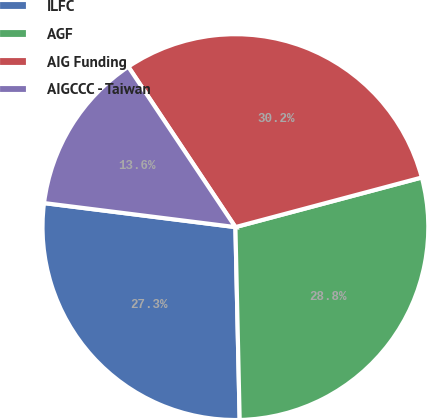Convert chart. <chart><loc_0><loc_0><loc_500><loc_500><pie_chart><fcel>ILFC<fcel>AGF<fcel>AIG Funding<fcel>AIGCCC - Taiwan<nl><fcel>27.34%<fcel>28.79%<fcel>30.23%<fcel>13.64%<nl></chart> 